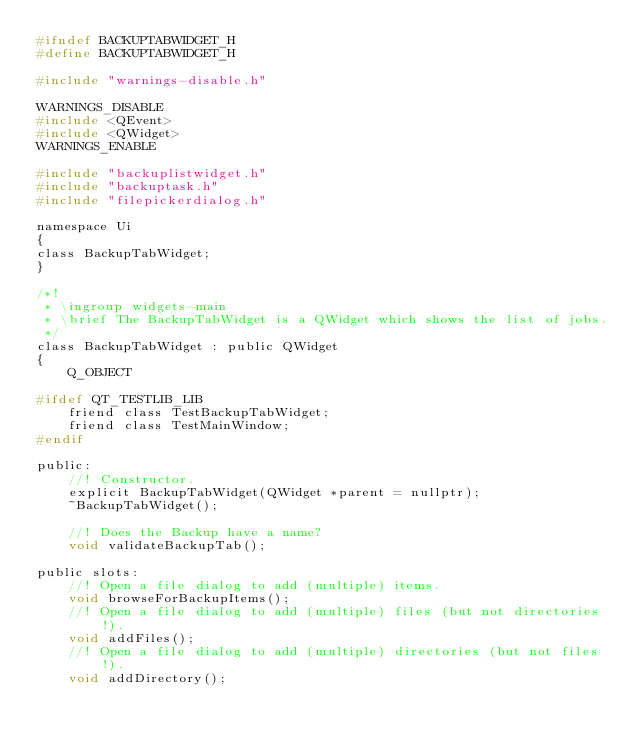Convert code to text. <code><loc_0><loc_0><loc_500><loc_500><_C_>#ifndef BACKUPTABWIDGET_H
#define BACKUPTABWIDGET_H

#include "warnings-disable.h"

WARNINGS_DISABLE
#include <QEvent>
#include <QWidget>
WARNINGS_ENABLE

#include "backuplistwidget.h"
#include "backuptask.h"
#include "filepickerdialog.h"

namespace Ui
{
class BackupTabWidget;
}

/*!
 * \ingroup widgets-main
 * \brief The BackupTabWidget is a QWidget which shows the list of jobs.
 */
class BackupTabWidget : public QWidget
{
    Q_OBJECT

#ifdef QT_TESTLIB_LIB
    friend class TestBackupTabWidget;
    friend class TestMainWindow;
#endif

public:
    //! Constructor.
    explicit BackupTabWidget(QWidget *parent = nullptr);
    ~BackupTabWidget();

    //! Does the Backup have a name?
    void validateBackupTab();

public slots:
    //! Open a file dialog to add (multiple) items.
    void browseForBackupItems();
    //! Open a file dialog to add (multiple) files (but not directories!).
    void addFiles();
    //! Open a file dialog to add (multiple) directories (but not files!).
    void addDirectory();</code> 